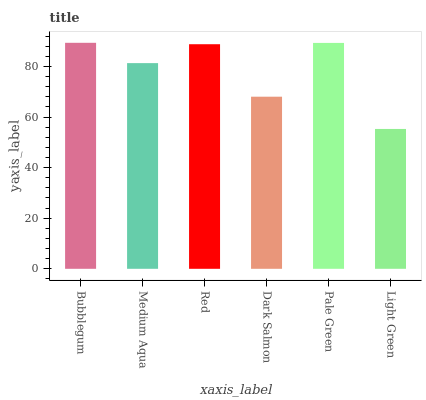Is Light Green the minimum?
Answer yes or no. Yes. Is Bubblegum the maximum?
Answer yes or no. Yes. Is Medium Aqua the minimum?
Answer yes or no. No. Is Medium Aqua the maximum?
Answer yes or no. No. Is Bubblegum greater than Medium Aqua?
Answer yes or no. Yes. Is Medium Aqua less than Bubblegum?
Answer yes or no. Yes. Is Medium Aqua greater than Bubblegum?
Answer yes or no. No. Is Bubblegum less than Medium Aqua?
Answer yes or no. No. Is Red the high median?
Answer yes or no. Yes. Is Medium Aqua the low median?
Answer yes or no. Yes. Is Medium Aqua the high median?
Answer yes or no. No. Is Dark Salmon the low median?
Answer yes or no. No. 